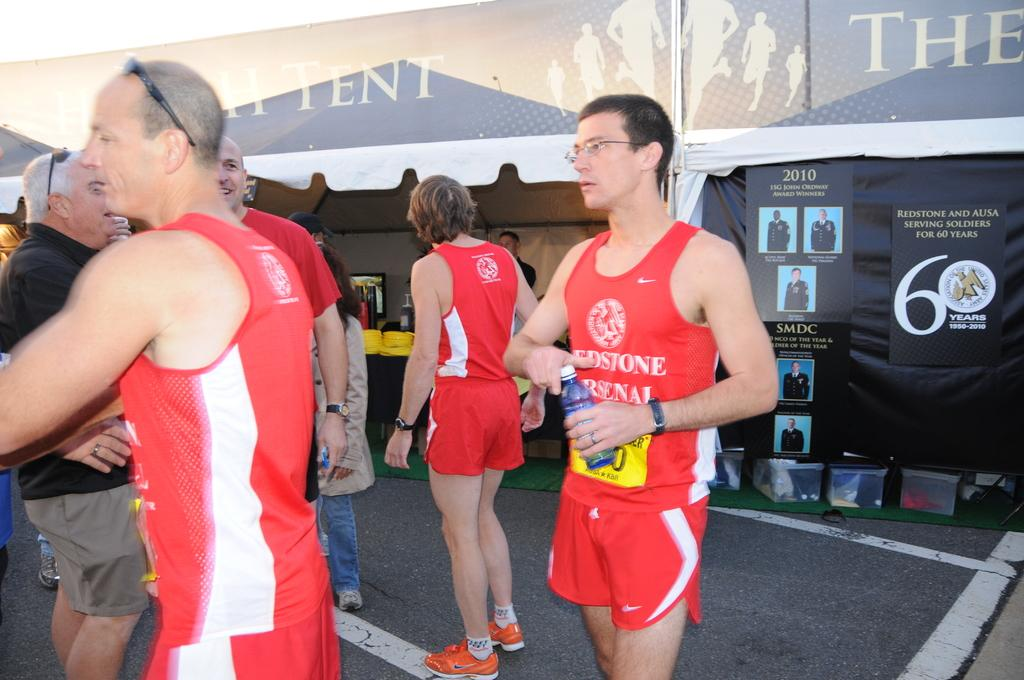<image>
Render a clear and concise summary of the photo. a man wearing a redstone arsenol shirt with water 